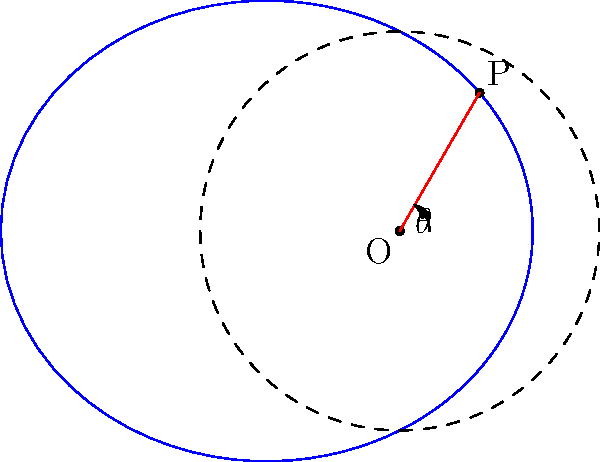A railway track in Catalonia is represented in polar form by the equation $r = \frac{100}{1 + 0.5\cos\theta}$, where $r$ is in meters. At the point P where $\theta = \frac{\pi}{3}$, calculate the radius of curvature of the track. Round your answer to the nearest meter. To find the radius of curvature, we'll use the formula for polar coordinates:

$$R = \frac{(r^2 + (\frac{dr}{d\theta})^2)^{3/2}}{|r^2 + 2(\frac{dr}{d\theta})^2 - r\frac{d^2r}{d\theta^2}|}$$

Steps:
1) First, we need to find $\frac{dr}{d\theta}$ and $\frac{d^2r}{d\theta^2}$:

   $r = \frac{100}{1 + 0.5\cos\theta}$
   $\frac{dr}{d\theta} = \frac{50\sin\theta}{(1 + 0.5\cos\theta)^2}$
   $\frac{d^2r}{d\theta^2} = \frac{50\cos\theta}{(1 + 0.5\cos\theta)^2} + \frac{100\sin^2\theta}{(1 + 0.5\cos\theta)^3}$

2) At $\theta = \frac{\pi}{3}$:
   $\cos\frac{\pi}{3} = \frac{1}{2}$, $\sin\frac{\pi}{3} = \frac{\sqrt{3}}{2}$

3) Calculate $r$ at $\theta = \frac{\pi}{3}$:
   $r = \frac{100}{1 + 0.5(\frac{1}{2})} = \frac{100}{1.25} = 80$

4) Calculate $\frac{dr}{d\theta}$ at $\theta = \frac{\pi}{3}$:
   $\frac{dr}{d\theta} = \frac{50(\frac{\sqrt{3}}{2})}{(1.25)^2} = 24\sqrt{3}$

5) Calculate $\frac{d^2r}{d\theta^2}$ at $\theta = \frac{\pi}{3}$:
   $\frac{d^2r}{d\theta^2} = \frac{50(\frac{1}{2})}{(1.25)^2} + \frac{100(\frac{3}{4})}{(1.25)^3} = 20 + 38.4 = 58.4$

6) Now, substitute these values into the radius of curvature formula:

   $R = \frac{(80^2 + (24\sqrt{3})^2)^{3/2}}{|80^2 + 2(24\sqrt{3})^2 - 80(58.4)|}$

7) Simplify and calculate:
   $R \approx 133.33$ meters

8) Rounding to the nearest meter:
   $R \approx 133$ meters
Answer: 133 meters 